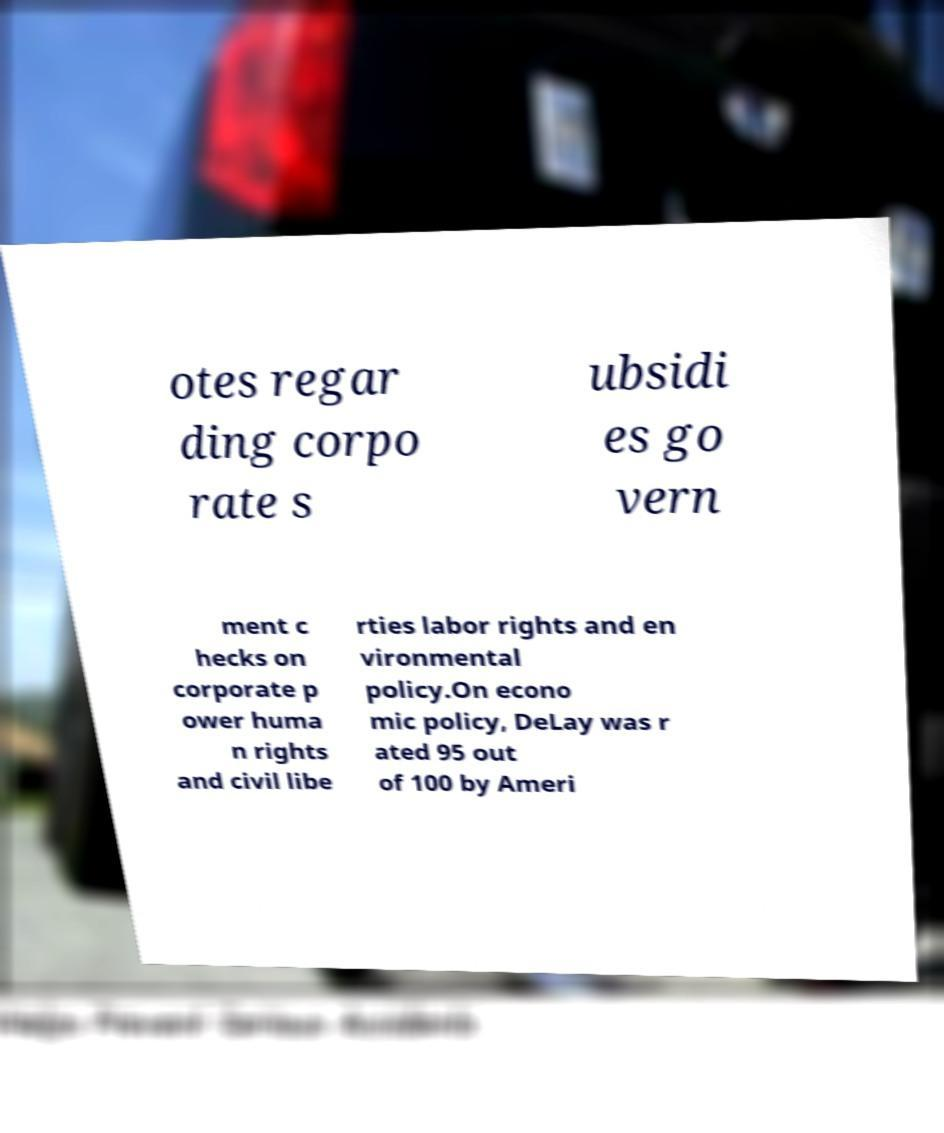Please read and relay the text visible in this image. What does it say? otes regar ding corpo rate s ubsidi es go vern ment c hecks on corporate p ower huma n rights and civil libe rties labor rights and en vironmental policy.On econo mic policy, DeLay was r ated 95 out of 100 by Ameri 